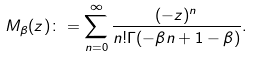Convert formula to latex. <formula><loc_0><loc_0><loc_500><loc_500>M _ { \beta } ( z ) \colon = \sum _ { n = 0 } ^ { \infty } \frac { ( - z ) ^ { n } } { n ! \Gamma ( - \beta n + 1 - \beta ) } .</formula> 